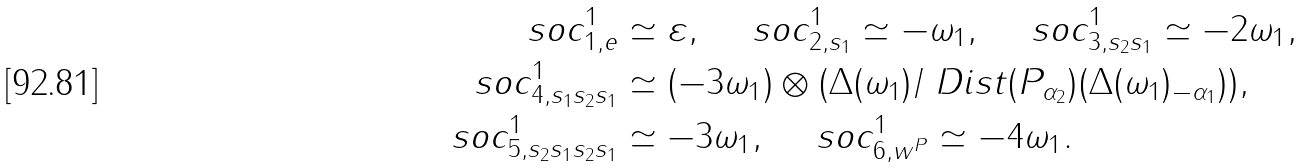<formula> <loc_0><loc_0><loc_500><loc_500>\ s o c _ { 1 , e } ^ { 1 } & \simeq \varepsilon , \quad \ s o c _ { 2 , s _ { 1 } } ^ { 1 } \simeq - \omega _ { 1 } , \quad \ s o c _ { 3 , s _ { 2 } s _ { 1 } } ^ { 1 } \simeq - 2 \omega _ { 1 } , \\ \ s o c _ { 4 , s _ { 1 } s _ { 2 } s _ { 1 } } ^ { 1 } & \simeq ( - 3 \omega _ { 1 } ) \otimes ( \Delta ( \omega _ { 1 } ) / \ D i s t ( P _ { \alpha _ { 2 } } ) ( \Delta ( \omega _ { 1 } ) _ { - \alpha _ { 1 } } ) ) , \\ \ s o c _ { 5 , s _ { 2 } s _ { 1 } s _ { 2 } s _ { 1 } } ^ { 1 } & \simeq - 3 \omega _ { 1 } , \quad \ s o c _ { 6 , w ^ { P } } ^ { 1 } \simeq - 4 \omega _ { 1 } .</formula> 